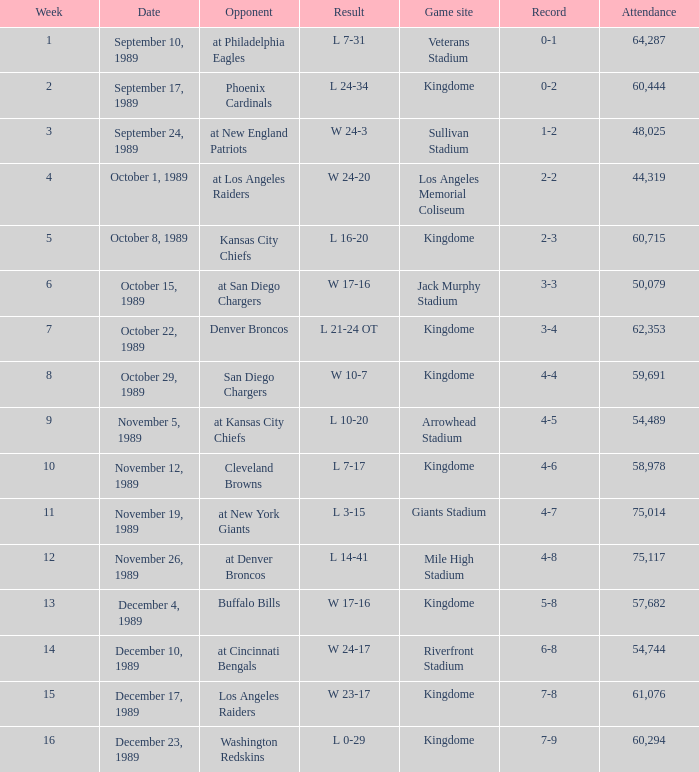Name the result for kingdome game site and opponent of denver broncos L 21-24 OT. 